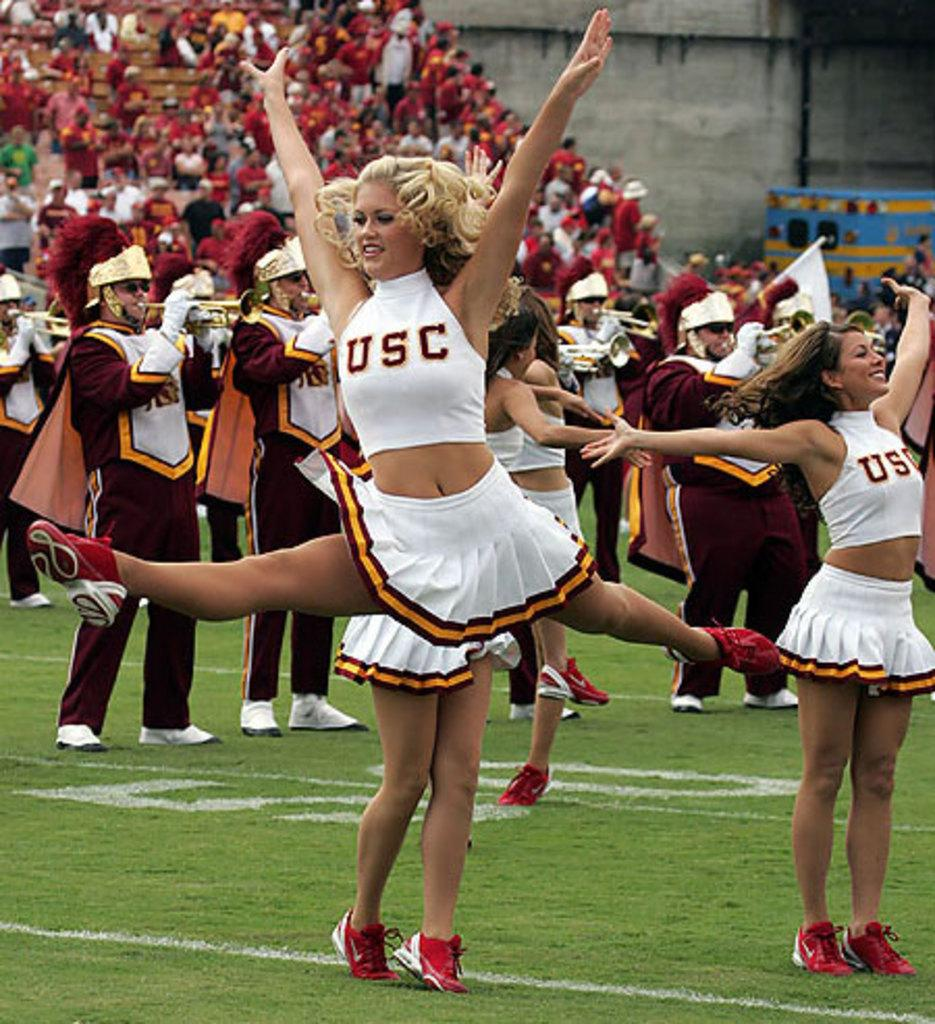Provide a one-sentence caption for the provided image. A USC cheerleader does the splits in mid air as the band plays behind her. 